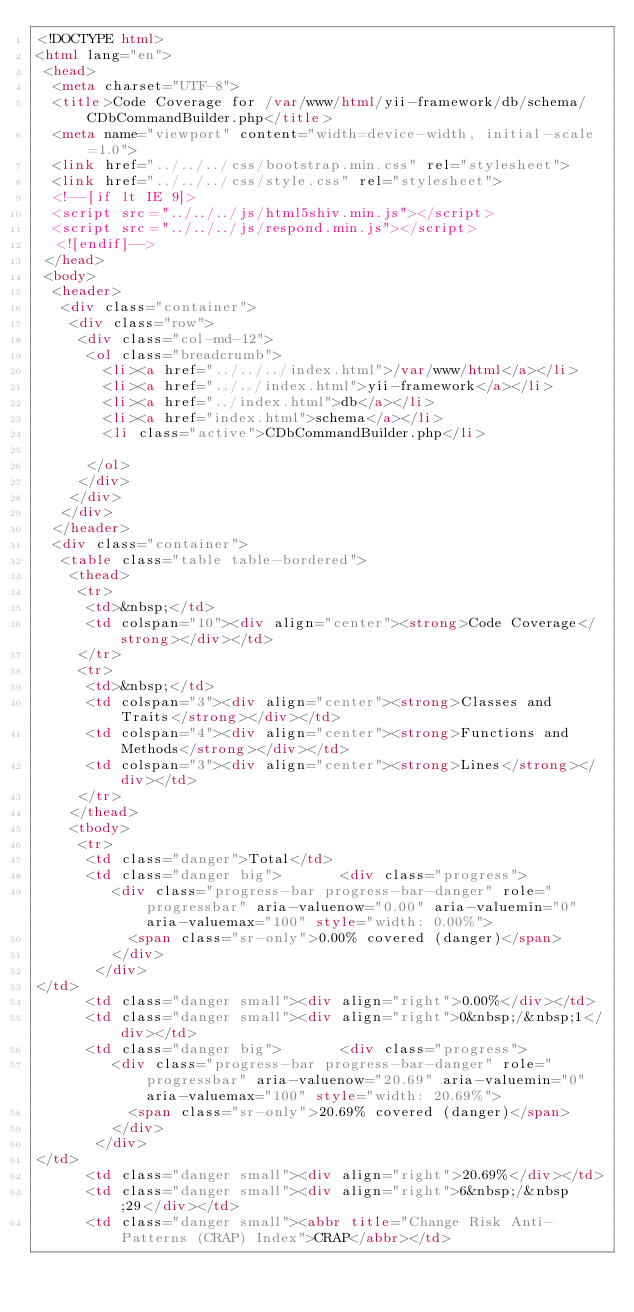Convert code to text. <code><loc_0><loc_0><loc_500><loc_500><_HTML_><!DOCTYPE html>
<html lang="en">
 <head>
  <meta charset="UTF-8">
  <title>Code Coverage for /var/www/html/yii-framework/db/schema/CDbCommandBuilder.php</title>
  <meta name="viewport" content="width=device-width, initial-scale=1.0">
  <link href="../../../css/bootstrap.min.css" rel="stylesheet">
  <link href="../../../css/style.css" rel="stylesheet">
  <!--[if lt IE 9]>
  <script src="../../../js/html5shiv.min.js"></script>
  <script src="../../../js/respond.min.js"></script>
  <![endif]-->
 </head>
 <body>
  <header>
   <div class="container">
    <div class="row">
     <div class="col-md-12">
      <ol class="breadcrumb">
        <li><a href="../../../index.html">/var/www/html</a></li>
        <li><a href="../../index.html">yii-framework</a></li>
        <li><a href="../index.html">db</a></li>
        <li><a href="index.html">schema</a></li>
        <li class="active">CDbCommandBuilder.php</li>

      </ol>
     </div>
    </div>
   </div>
  </header>
  <div class="container">
   <table class="table table-bordered">
    <thead>
     <tr>
      <td>&nbsp;</td>
      <td colspan="10"><div align="center"><strong>Code Coverage</strong></div></td>
     </tr>
     <tr>
      <td>&nbsp;</td>
      <td colspan="3"><div align="center"><strong>Classes and Traits</strong></div></td>
      <td colspan="4"><div align="center"><strong>Functions and Methods</strong></div></td>
      <td colspan="3"><div align="center"><strong>Lines</strong></div></td>
     </tr>
    </thead>
    <tbody>
     <tr>
      <td class="danger">Total</td>
      <td class="danger big">       <div class="progress">
         <div class="progress-bar progress-bar-danger" role="progressbar" aria-valuenow="0.00" aria-valuemin="0" aria-valuemax="100" style="width: 0.00%">
           <span class="sr-only">0.00% covered (danger)</span>
         </div>
       </div>
</td>
      <td class="danger small"><div align="right">0.00%</div></td>
      <td class="danger small"><div align="right">0&nbsp;/&nbsp;1</div></td>
      <td class="danger big">       <div class="progress">
         <div class="progress-bar progress-bar-danger" role="progressbar" aria-valuenow="20.69" aria-valuemin="0" aria-valuemax="100" style="width: 20.69%">
           <span class="sr-only">20.69% covered (danger)</span>
         </div>
       </div>
</td>
      <td class="danger small"><div align="right">20.69%</div></td>
      <td class="danger small"><div align="right">6&nbsp;/&nbsp;29</div></td>
      <td class="danger small"><abbr title="Change Risk Anti-Patterns (CRAP) Index">CRAP</abbr></td></code> 